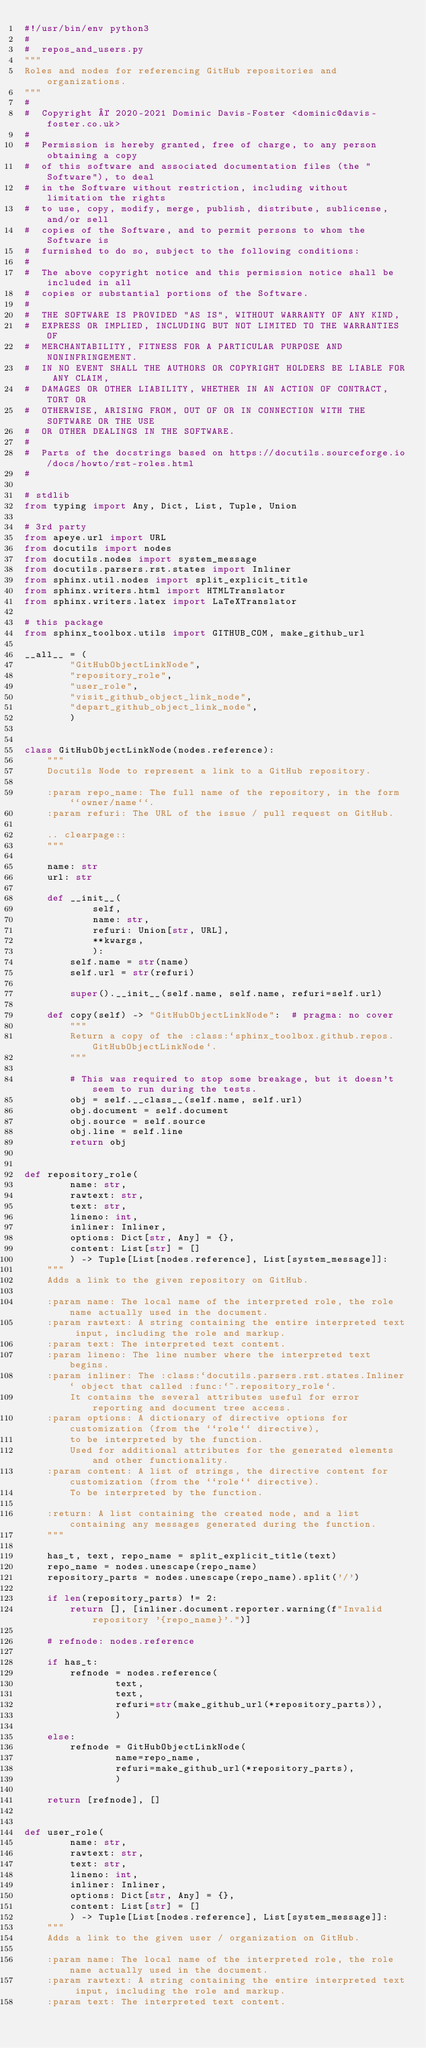Convert code to text. <code><loc_0><loc_0><loc_500><loc_500><_Python_>#!/usr/bin/env python3
#
#  repos_and_users.py
"""
Roles and nodes for referencing GitHub repositories and organizations.
"""
#
#  Copyright © 2020-2021 Dominic Davis-Foster <dominic@davis-foster.co.uk>
#
#  Permission is hereby granted, free of charge, to any person obtaining a copy
#  of this software and associated documentation files (the "Software"), to deal
#  in the Software without restriction, including without limitation the rights
#  to use, copy, modify, merge, publish, distribute, sublicense, and/or sell
#  copies of the Software, and to permit persons to whom the Software is
#  furnished to do so, subject to the following conditions:
#
#  The above copyright notice and this permission notice shall be included in all
#  copies or substantial portions of the Software.
#
#  THE SOFTWARE IS PROVIDED "AS IS", WITHOUT WARRANTY OF ANY KIND,
#  EXPRESS OR IMPLIED, INCLUDING BUT NOT LIMITED TO THE WARRANTIES OF
#  MERCHANTABILITY, FITNESS FOR A PARTICULAR PURPOSE AND NONINFRINGEMENT.
#  IN NO EVENT SHALL THE AUTHORS OR COPYRIGHT HOLDERS BE LIABLE FOR ANY CLAIM,
#  DAMAGES OR OTHER LIABILITY, WHETHER IN AN ACTION OF CONTRACT, TORT OR
#  OTHERWISE, ARISING FROM, OUT OF OR IN CONNECTION WITH THE SOFTWARE OR THE USE
#  OR OTHER DEALINGS IN THE SOFTWARE.
#
#  Parts of the docstrings based on https://docutils.sourceforge.io/docs/howto/rst-roles.html
#

# stdlib
from typing import Any, Dict, List, Tuple, Union

# 3rd party
from apeye.url import URL
from docutils import nodes
from docutils.nodes import system_message
from docutils.parsers.rst.states import Inliner
from sphinx.util.nodes import split_explicit_title
from sphinx.writers.html import HTMLTranslator
from sphinx.writers.latex import LaTeXTranslator

# this package
from sphinx_toolbox.utils import GITHUB_COM, make_github_url

__all__ = (
		"GitHubObjectLinkNode",
		"repository_role",
		"user_role",
		"visit_github_object_link_node",
		"depart_github_object_link_node",
		)


class GitHubObjectLinkNode(nodes.reference):
	"""
	Docutils Node to represent a link to a GitHub repository.

	:param repo_name: The full name of the repository, in the form ``owner/name``.
	:param refuri: The URL of the issue / pull request on GitHub.

	.. clearpage::
	"""

	name: str
	url: str

	def __init__(
			self,
			name: str,
			refuri: Union[str, URL],
			**kwargs,
			):
		self.name = str(name)
		self.url = str(refuri)

		super().__init__(self.name, self.name, refuri=self.url)

	def copy(self) -> "GitHubObjectLinkNode":  # pragma: no cover
		"""
		Return a copy of the :class:`sphinx_toolbox.github.repos.GitHubObjectLinkNode`.
		"""

		# This was required to stop some breakage, but it doesn't seem to run during the tests.
		obj = self.__class__(self.name, self.url)
		obj.document = self.document
		obj.source = self.source
		obj.line = self.line
		return obj


def repository_role(
		name: str,
		rawtext: str,
		text: str,
		lineno: int,
		inliner: Inliner,
		options: Dict[str, Any] = {},
		content: List[str] = []
		) -> Tuple[List[nodes.reference], List[system_message]]:
	"""
	Adds a link to the given repository on GitHub.

	:param name: The local name of the interpreted role, the role name actually used in the document.
	:param rawtext: A string containing the entire interpreted text input, including the role and markup.
	:param text: The interpreted text content.
	:param lineno: The line number where the interpreted text begins.
	:param inliner: The :class:`docutils.parsers.rst.states.Inliner` object that called :func:`~.repository_role`.
		It contains the several attributes useful for error reporting and document tree access.
	:param options: A dictionary of directive options for customization (from the ``role`` directive),
		to be interpreted by the function.
		Used for additional attributes for the generated elements and other functionality.
	:param content: A list of strings, the directive content for customization (from the ``role`` directive).
		To be interpreted by the function.

	:return: A list containing the created node, and a list containing any messages generated during the function.
	"""

	has_t, text, repo_name = split_explicit_title(text)
	repo_name = nodes.unescape(repo_name)
	repository_parts = nodes.unescape(repo_name).split('/')

	if len(repository_parts) != 2:
		return [], [inliner.document.reporter.warning(f"Invalid repository '{repo_name}'.")]

	# refnode: nodes.reference

	if has_t:
		refnode = nodes.reference(
				text,
				text,
				refuri=str(make_github_url(*repository_parts)),
				)

	else:
		refnode = GitHubObjectLinkNode(
				name=repo_name,
				refuri=make_github_url(*repository_parts),
				)

	return [refnode], []


def user_role(
		name: str,
		rawtext: str,
		text: str,
		lineno: int,
		inliner: Inliner,
		options: Dict[str, Any] = {},
		content: List[str] = []
		) -> Tuple[List[nodes.reference], List[system_message]]:
	"""
	Adds a link to the given user / organization on GitHub.

	:param name: The local name of the interpreted role, the role name actually used in the document.
	:param rawtext: A string containing the entire interpreted text input, including the role and markup.
	:param text: The interpreted text content.</code> 